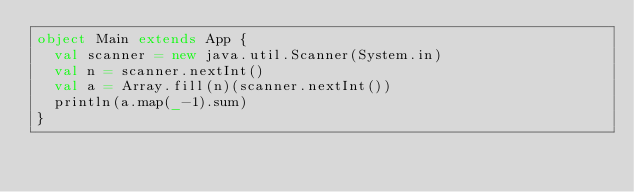Convert code to text. <code><loc_0><loc_0><loc_500><loc_500><_Scala_>object Main extends App {
  val scanner = new java.util.Scanner(System.in)
  val n = scanner.nextInt()
  val a = Array.fill(n)(scanner.nextInt())
  println(a.map(_-1).sum)
}</code> 